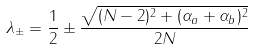Convert formula to latex. <formula><loc_0><loc_0><loc_500><loc_500>\lambda _ { \pm } = \frac { 1 } { 2 } \pm \frac { \sqrt { ( N - 2 ) ^ { 2 } + ( \alpha _ { a } + \alpha _ { b } ) ^ { 2 } } } { 2 N }</formula> 